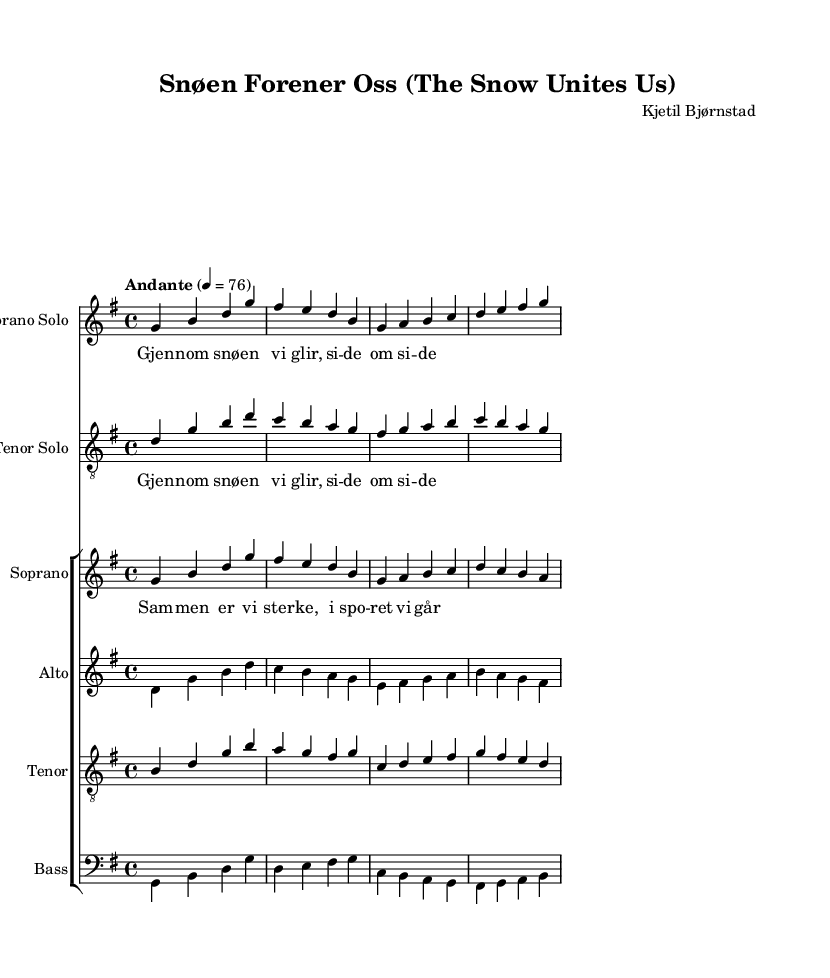What is the key signature of this music? The key signature is G major, which has one sharp (F sharp). This can be identified by looking at the key signature on the left side of the staff.
Answer: G major What is the time signature of this music? The time signature is 4/4, indicated by the fraction at the beginning of the piece. This means there are four beats in each measure and the quarter note gets one beat.
Answer: 4/4 What is the tempo marking for this piece? The tempo marking is "Andante", which is a term indicating a moderately slow tempo, typically around 76 beats per minute. This is found in the tempo directive at the beginning of the score.
Answer: Andante How many voices are in the choir staff? There are four voices in the choir staff: soprano, alto, tenor, and bass. This can be seen in the choir staff section, where each part is indicated.
Answer: Four What is the title of this opera? The title of this opera is "Snøen Forener Oss". This is clearly specified in the header section at the top of the score.
Answer: Snøen Forener Oss What lyrical theme is present in the chorus? The lyrical theme present in the chorus is about teamwork and strength in sports. The repeated line "Sam – men er vi ster – ke, i spo – ret vi går" suggests unity and collective strength.
Answer: Teamwork Which instrument is the soprano solo associated with? The soprano solo is associated with the staff labeled "Soprano Solo", indicating that it is performed by a soprano voice. This is found in the staff section of the score.
Answer: Soprano Solo 